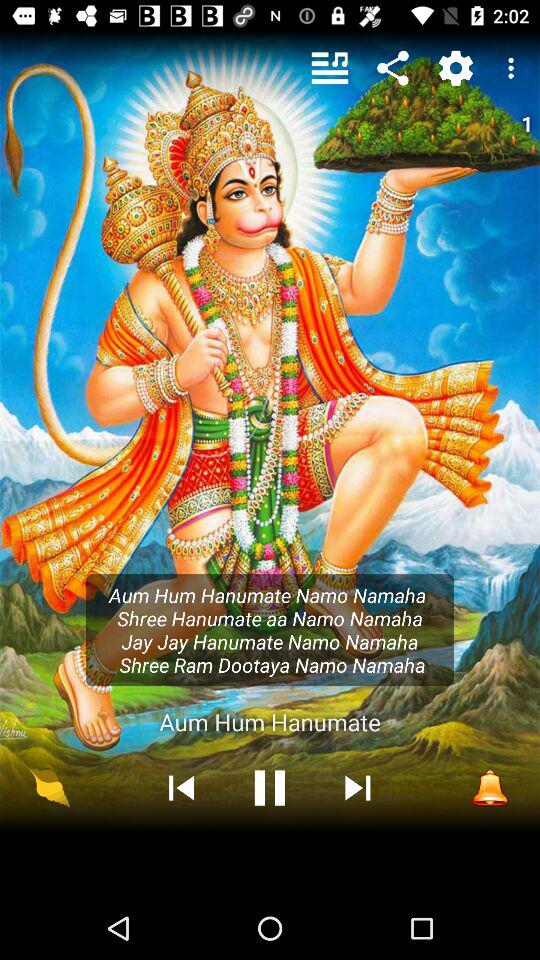What is the name of the song playing? The name of the song playing is "Aum Hum Hanumate". 